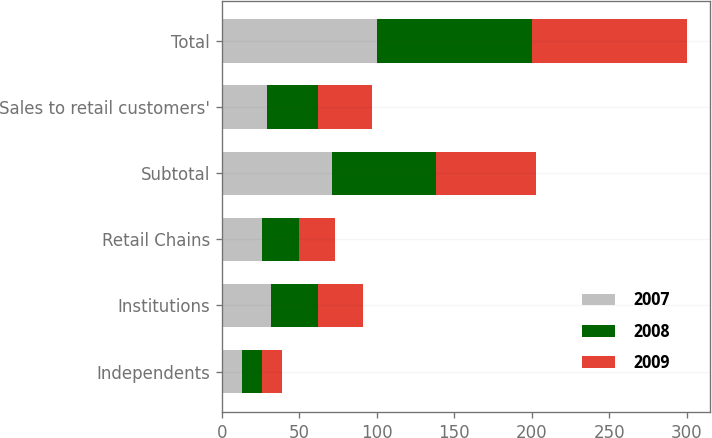<chart> <loc_0><loc_0><loc_500><loc_500><stacked_bar_chart><ecel><fcel>Independents<fcel>Institutions<fcel>Retail Chains<fcel>Subtotal<fcel>Sales to retail customers'<fcel>Total<nl><fcel>2007<fcel>13<fcel>32<fcel>26<fcel>71<fcel>29<fcel>100<nl><fcel>2008<fcel>13<fcel>30<fcel>24<fcel>67<fcel>33<fcel>100<nl><fcel>2009<fcel>13<fcel>29<fcel>23<fcel>65<fcel>35<fcel>100<nl></chart> 